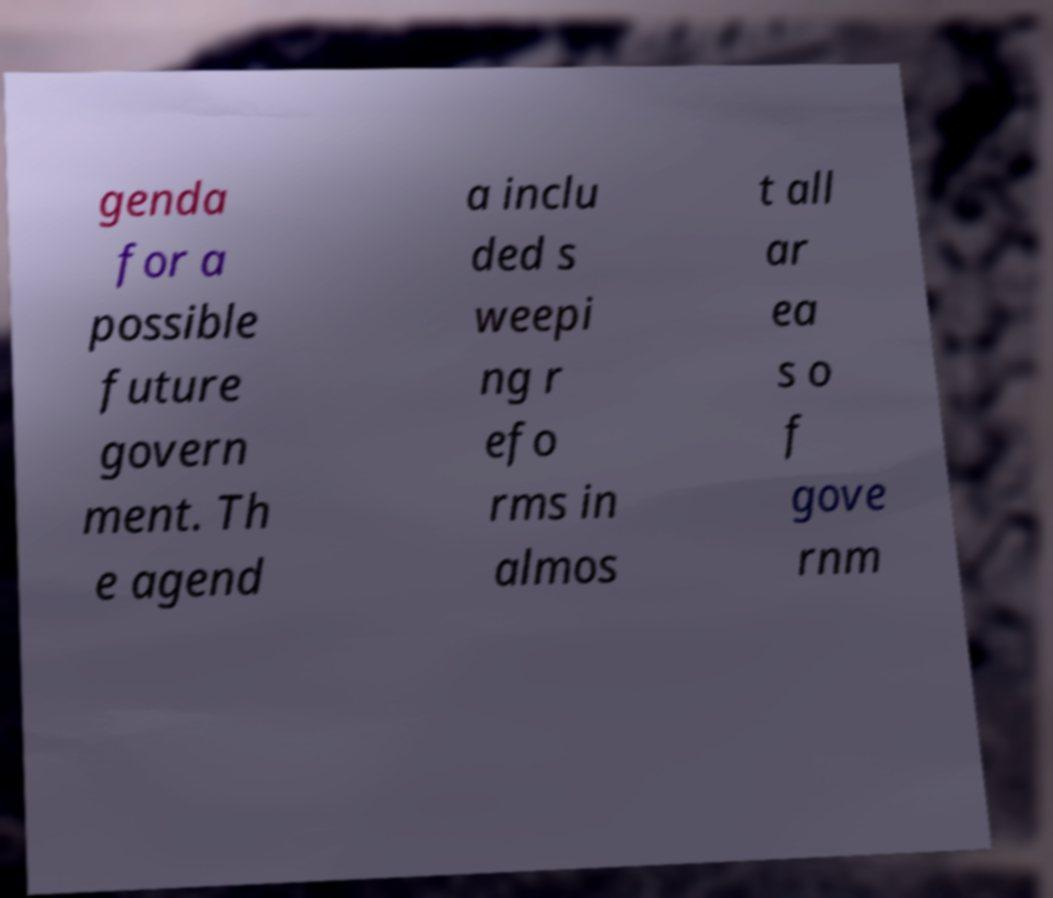Please read and relay the text visible in this image. What does it say? genda for a possible future govern ment. Th e agend a inclu ded s weepi ng r efo rms in almos t all ar ea s o f gove rnm 